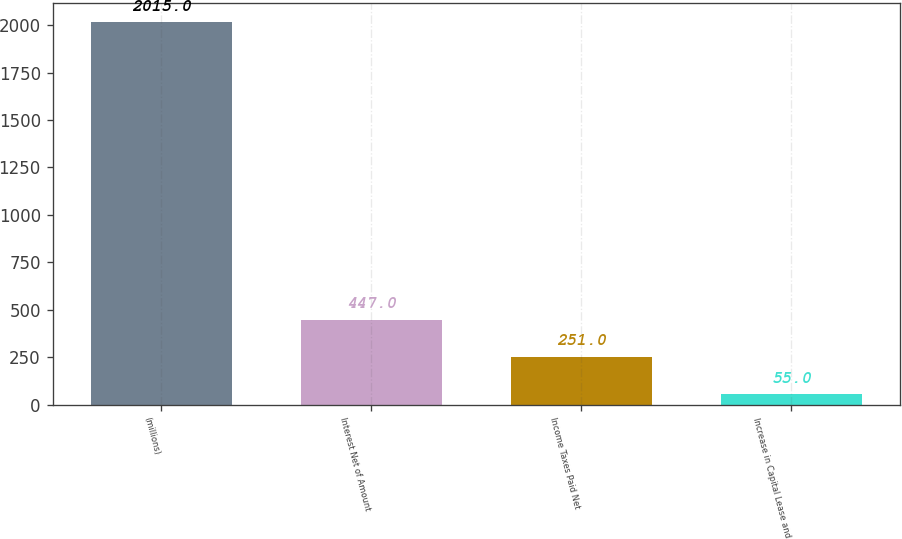Convert chart to OTSL. <chart><loc_0><loc_0><loc_500><loc_500><bar_chart><fcel>(millions)<fcel>Interest Net of Amount<fcel>Income Taxes Paid Net<fcel>Increase in Capital Lease and<nl><fcel>2015<fcel>447<fcel>251<fcel>55<nl></chart> 